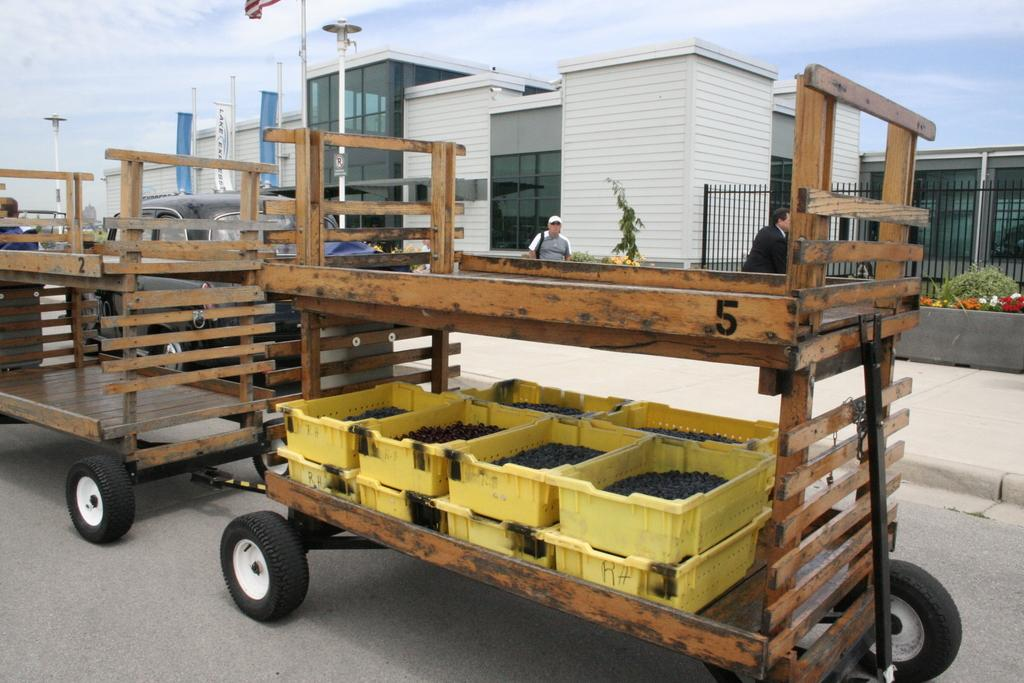What type of carts are on the road in the image? There are wooden carts on the road in the image. What are the wooden carts carrying? The wooden carts are carrying yellow tubs. Can you describe the contents of the yellow tubs? There is something inside the yellow tubs, but the specific contents are not visible in the image. What can be seen in the background of the image? There are buildings, trees, a railing, and lamp poles in the background. Are there any people visible in the image? Yes, people are visible in the background. What type of appliance is being used to cut the knot in the image? There is no appliance or knot present in the image. 